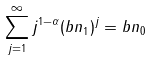<formula> <loc_0><loc_0><loc_500><loc_500>\sum _ { j = 1 } ^ { \infty } j ^ { 1 - \alpha } ( b n _ { 1 } ) ^ { j } = b n _ { 0 }</formula> 